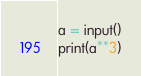Convert code to text. <code><loc_0><loc_0><loc_500><loc_500><_Python_>a = input()
print(a**3)
</code> 